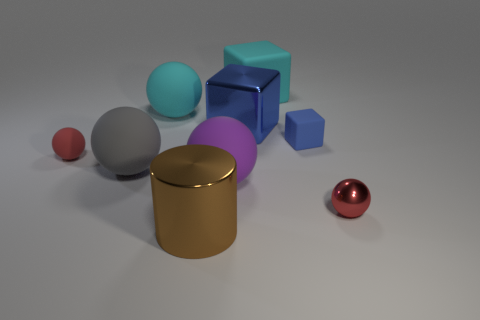Subtract all purple spheres. How many spheres are left? 4 Subtract all purple spheres. How many spheres are left? 4 Subtract all blue spheres. Subtract all blue cubes. How many spheres are left? 5 Add 1 big brown cylinders. How many objects exist? 10 Subtract all blocks. How many objects are left? 6 Add 8 big blocks. How many big blocks exist? 10 Subtract 0 yellow spheres. How many objects are left? 9 Subtract all cyan matte objects. Subtract all purple balls. How many objects are left? 6 Add 5 metallic cylinders. How many metallic cylinders are left? 6 